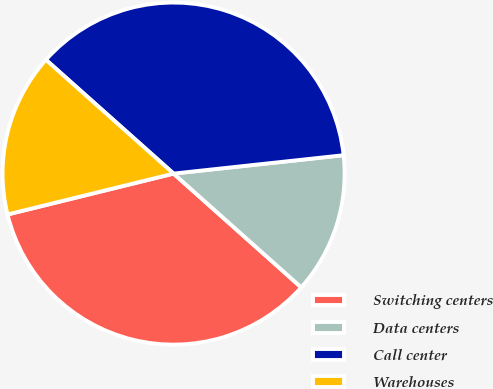Convert chart to OTSL. <chart><loc_0><loc_0><loc_500><loc_500><pie_chart><fcel>Switching centers<fcel>Data centers<fcel>Call center<fcel>Warehouses<nl><fcel>34.57%<fcel>13.3%<fcel>36.7%<fcel>15.43%<nl></chart> 